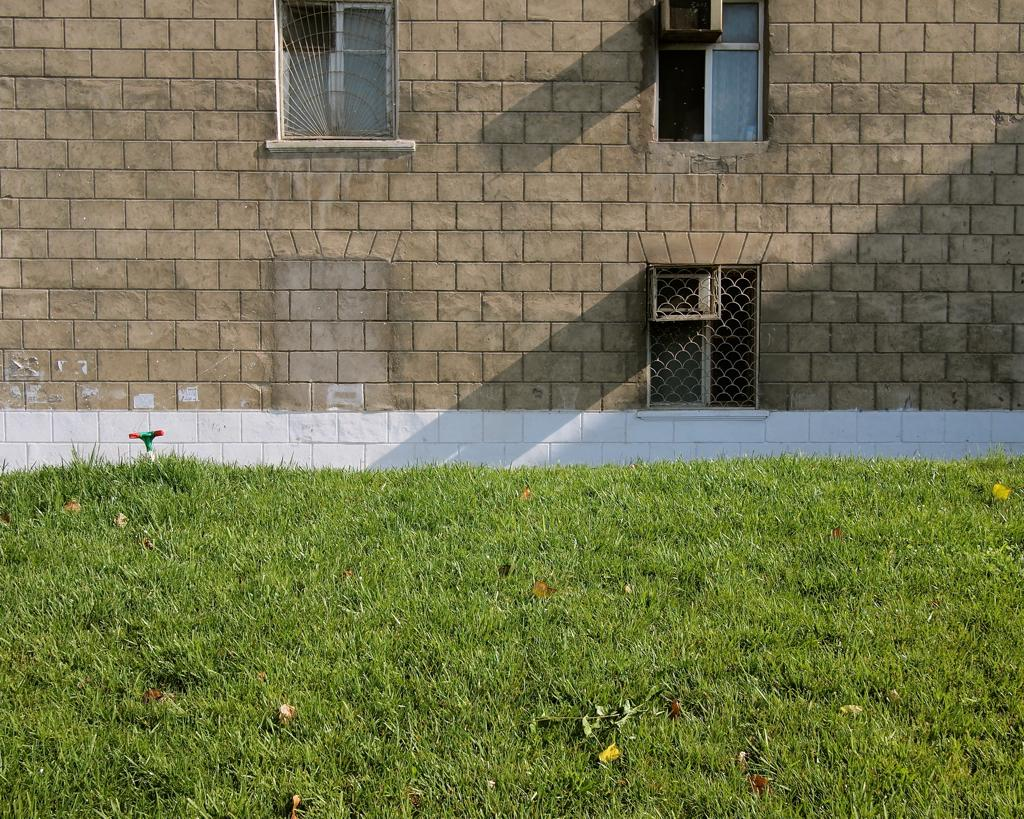What type of structure is in the image? There is a building in the image. What can be seen at the bottom of the image? Grass and leaves are visible at the bottom of the image. What feature of the building can be seen at the top of the image? There are windows visible at the top of the image. What type of linen is draped over the building in the image? There is no linen draped over the building in the image. Can you see any ducks swimming in the grass at the bottom of the image? There are no ducks present in the image; only grass and leaves can be seen at the bottom. 